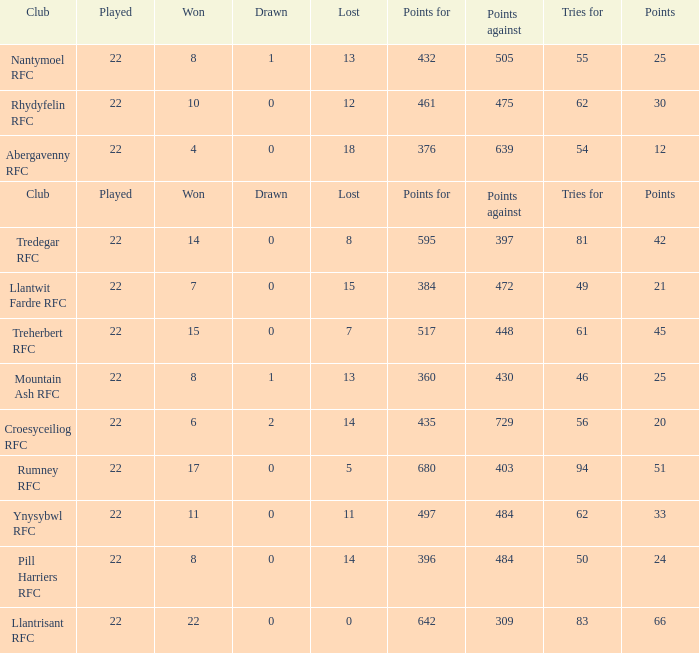How many matches were drawn by the teams that won exactly 10? 1.0. 